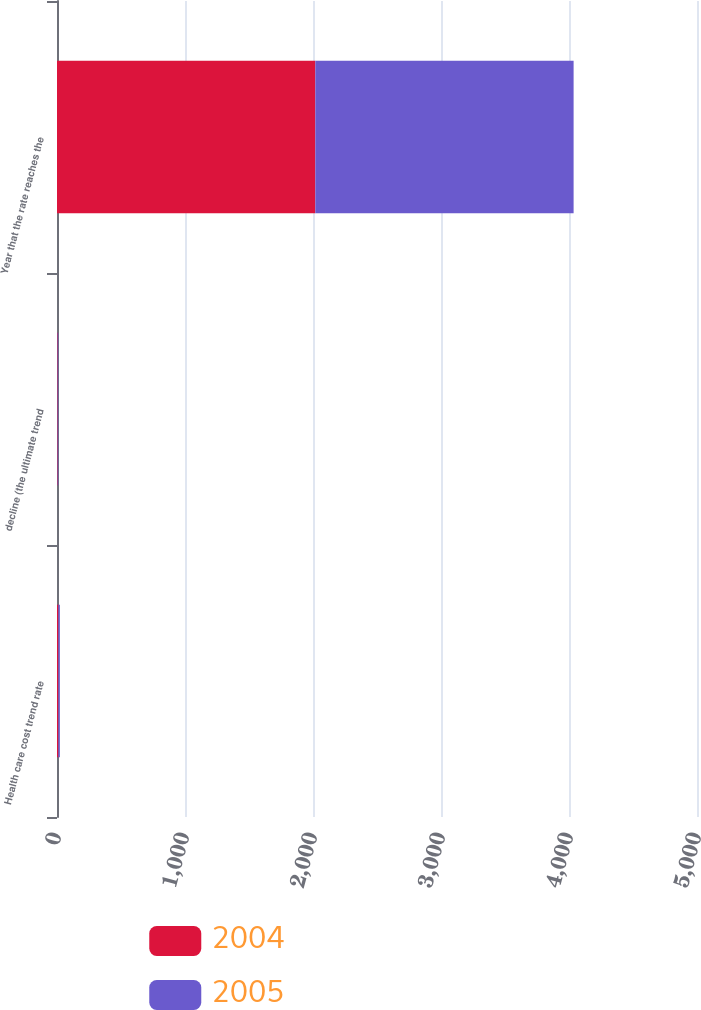Convert chart to OTSL. <chart><loc_0><loc_0><loc_500><loc_500><stacked_bar_chart><ecel><fcel>Health care cost trend rate<fcel>decline (the ultimate trend<fcel>Year that the rate reaches the<nl><fcel>2004<fcel>11<fcel>5<fcel>2018<nl><fcel>2005<fcel>11.5<fcel>5<fcel>2018<nl></chart> 